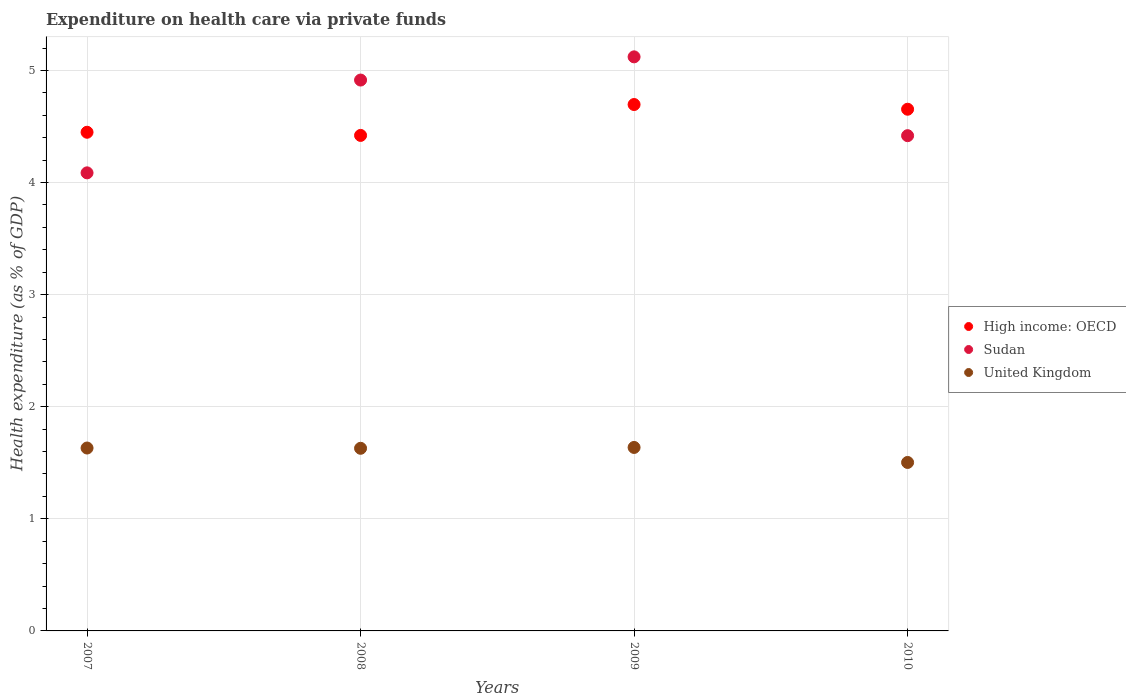What is the expenditure made on health care in Sudan in 2008?
Offer a terse response. 4.91. Across all years, what is the maximum expenditure made on health care in High income: OECD?
Make the answer very short. 4.7. Across all years, what is the minimum expenditure made on health care in United Kingdom?
Your response must be concise. 1.5. In which year was the expenditure made on health care in Sudan minimum?
Give a very brief answer. 2007. What is the total expenditure made on health care in United Kingdom in the graph?
Ensure brevity in your answer.  6.4. What is the difference between the expenditure made on health care in High income: OECD in 2007 and that in 2009?
Keep it short and to the point. -0.25. What is the difference between the expenditure made on health care in United Kingdom in 2009 and the expenditure made on health care in Sudan in 2008?
Your response must be concise. -3.28. What is the average expenditure made on health care in United Kingdom per year?
Offer a very short reply. 1.6. In the year 2009, what is the difference between the expenditure made on health care in High income: OECD and expenditure made on health care in United Kingdom?
Keep it short and to the point. 3.06. What is the ratio of the expenditure made on health care in High income: OECD in 2007 to that in 2010?
Make the answer very short. 0.96. Is the expenditure made on health care in United Kingdom in 2007 less than that in 2009?
Keep it short and to the point. Yes. Is the difference between the expenditure made on health care in High income: OECD in 2009 and 2010 greater than the difference between the expenditure made on health care in United Kingdom in 2009 and 2010?
Keep it short and to the point. No. What is the difference between the highest and the second highest expenditure made on health care in United Kingdom?
Ensure brevity in your answer.  0.01. What is the difference between the highest and the lowest expenditure made on health care in High income: OECD?
Keep it short and to the point. 0.28. In how many years, is the expenditure made on health care in Sudan greater than the average expenditure made on health care in Sudan taken over all years?
Your response must be concise. 2. Does the expenditure made on health care in Sudan monotonically increase over the years?
Give a very brief answer. No. Is the expenditure made on health care in Sudan strictly less than the expenditure made on health care in High income: OECD over the years?
Provide a succinct answer. No. How many years are there in the graph?
Offer a very short reply. 4. What is the difference between two consecutive major ticks on the Y-axis?
Make the answer very short. 1. Does the graph contain any zero values?
Your answer should be very brief. No. What is the title of the graph?
Ensure brevity in your answer.  Expenditure on health care via private funds. What is the label or title of the X-axis?
Offer a very short reply. Years. What is the label or title of the Y-axis?
Your response must be concise. Health expenditure (as % of GDP). What is the Health expenditure (as % of GDP) in High income: OECD in 2007?
Ensure brevity in your answer.  4.45. What is the Health expenditure (as % of GDP) of Sudan in 2007?
Your response must be concise. 4.09. What is the Health expenditure (as % of GDP) in United Kingdom in 2007?
Your answer should be very brief. 1.63. What is the Health expenditure (as % of GDP) in High income: OECD in 2008?
Make the answer very short. 4.42. What is the Health expenditure (as % of GDP) in Sudan in 2008?
Your answer should be compact. 4.91. What is the Health expenditure (as % of GDP) in United Kingdom in 2008?
Ensure brevity in your answer.  1.63. What is the Health expenditure (as % of GDP) of High income: OECD in 2009?
Provide a succinct answer. 4.7. What is the Health expenditure (as % of GDP) of Sudan in 2009?
Your answer should be compact. 5.12. What is the Health expenditure (as % of GDP) in United Kingdom in 2009?
Make the answer very short. 1.64. What is the Health expenditure (as % of GDP) of High income: OECD in 2010?
Your response must be concise. 4.65. What is the Health expenditure (as % of GDP) of Sudan in 2010?
Your answer should be very brief. 4.42. What is the Health expenditure (as % of GDP) in United Kingdom in 2010?
Your answer should be compact. 1.5. Across all years, what is the maximum Health expenditure (as % of GDP) of High income: OECD?
Your response must be concise. 4.7. Across all years, what is the maximum Health expenditure (as % of GDP) of Sudan?
Provide a succinct answer. 5.12. Across all years, what is the maximum Health expenditure (as % of GDP) of United Kingdom?
Your answer should be compact. 1.64. Across all years, what is the minimum Health expenditure (as % of GDP) in High income: OECD?
Offer a very short reply. 4.42. Across all years, what is the minimum Health expenditure (as % of GDP) of Sudan?
Give a very brief answer. 4.09. Across all years, what is the minimum Health expenditure (as % of GDP) of United Kingdom?
Your response must be concise. 1.5. What is the total Health expenditure (as % of GDP) of High income: OECD in the graph?
Give a very brief answer. 18.22. What is the total Health expenditure (as % of GDP) in Sudan in the graph?
Offer a terse response. 18.54. What is the total Health expenditure (as % of GDP) in United Kingdom in the graph?
Ensure brevity in your answer.  6.4. What is the difference between the Health expenditure (as % of GDP) of High income: OECD in 2007 and that in 2008?
Keep it short and to the point. 0.03. What is the difference between the Health expenditure (as % of GDP) in Sudan in 2007 and that in 2008?
Make the answer very short. -0.83. What is the difference between the Health expenditure (as % of GDP) of United Kingdom in 2007 and that in 2008?
Provide a succinct answer. 0. What is the difference between the Health expenditure (as % of GDP) in High income: OECD in 2007 and that in 2009?
Provide a short and direct response. -0.25. What is the difference between the Health expenditure (as % of GDP) in Sudan in 2007 and that in 2009?
Keep it short and to the point. -1.03. What is the difference between the Health expenditure (as % of GDP) in United Kingdom in 2007 and that in 2009?
Provide a short and direct response. -0.01. What is the difference between the Health expenditure (as % of GDP) of High income: OECD in 2007 and that in 2010?
Provide a short and direct response. -0.21. What is the difference between the Health expenditure (as % of GDP) of Sudan in 2007 and that in 2010?
Offer a very short reply. -0.33. What is the difference between the Health expenditure (as % of GDP) in United Kingdom in 2007 and that in 2010?
Offer a very short reply. 0.13. What is the difference between the Health expenditure (as % of GDP) in High income: OECD in 2008 and that in 2009?
Your answer should be very brief. -0.28. What is the difference between the Health expenditure (as % of GDP) of Sudan in 2008 and that in 2009?
Provide a succinct answer. -0.21. What is the difference between the Health expenditure (as % of GDP) in United Kingdom in 2008 and that in 2009?
Your answer should be very brief. -0.01. What is the difference between the Health expenditure (as % of GDP) of High income: OECD in 2008 and that in 2010?
Offer a very short reply. -0.23. What is the difference between the Health expenditure (as % of GDP) in Sudan in 2008 and that in 2010?
Make the answer very short. 0.5. What is the difference between the Health expenditure (as % of GDP) of United Kingdom in 2008 and that in 2010?
Give a very brief answer. 0.13. What is the difference between the Health expenditure (as % of GDP) in High income: OECD in 2009 and that in 2010?
Offer a very short reply. 0.04. What is the difference between the Health expenditure (as % of GDP) of Sudan in 2009 and that in 2010?
Keep it short and to the point. 0.7. What is the difference between the Health expenditure (as % of GDP) in United Kingdom in 2009 and that in 2010?
Your response must be concise. 0.13. What is the difference between the Health expenditure (as % of GDP) of High income: OECD in 2007 and the Health expenditure (as % of GDP) of Sudan in 2008?
Make the answer very short. -0.47. What is the difference between the Health expenditure (as % of GDP) of High income: OECD in 2007 and the Health expenditure (as % of GDP) of United Kingdom in 2008?
Offer a terse response. 2.82. What is the difference between the Health expenditure (as % of GDP) of Sudan in 2007 and the Health expenditure (as % of GDP) of United Kingdom in 2008?
Provide a short and direct response. 2.46. What is the difference between the Health expenditure (as % of GDP) of High income: OECD in 2007 and the Health expenditure (as % of GDP) of Sudan in 2009?
Your response must be concise. -0.67. What is the difference between the Health expenditure (as % of GDP) in High income: OECD in 2007 and the Health expenditure (as % of GDP) in United Kingdom in 2009?
Ensure brevity in your answer.  2.81. What is the difference between the Health expenditure (as % of GDP) in Sudan in 2007 and the Health expenditure (as % of GDP) in United Kingdom in 2009?
Offer a very short reply. 2.45. What is the difference between the Health expenditure (as % of GDP) in High income: OECD in 2007 and the Health expenditure (as % of GDP) in Sudan in 2010?
Offer a terse response. 0.03. What is the difference between the Health expenditure (as % of GDP) of High income: OECD in 2007 and the Health expenditure (as % of GDP) of United Kingdom in 2010?
Provide a short and direct response. 2.95. What is the difference between the Health expenditure (as % of GDP) of Sudan in 2007 and the Health expenditure (as % of GDP) of United Kingdom in 2010?
Your response must be concise. 2.58. What is the difference between the Health expenditure (as % of GDP) of High income: OECD in 2008 and the Health expenditure (as % of GDP) of Sudan in 2009?
Provide a short and direct response. -0.7. What is the difference between the Health expenditure (as % of GDP) of High income: OECD in 2008 and the Health expenditure (as % of GDP) of United Kingdom in 2009?
Ensure brevity in your answer.  2.78. What is the difference between the Health expenditure (as % of GDP) of Sudan in 2008 and the Health expenditure (as % of GDP) of United Kingdom in 2009?
Ensure brevity in your answer.  3.28. What is the difference between the Health expenditure (as % of GDP) of High income: OECD in 2008 and the Health expenditure (as % of GDP) of Sudan in 2010?
Keep it short and to the point. 0. What is the difference between the Health expenditure (as % of GDP) of High income: OECD in 2008 and the Health expenditure (as % of GDP) of United Kingdom in 2010?
Give a very brief answer. 2.92. What is the difference between the Health expenditure (as % of GDP) of Sudan in 2008 and the Health expenditure (as % of GDP) of United Kingdom in 2010?
Offer a very short reply. 3.41. What is the difference between the Health expenditure (as % of GDP) of High income: OECD in 2009 and the Health expenditure (as % of GDP) of Sudan in 2010?
Offer a very short reply. 0.28. What is the difference between the Health expenditure (as % of GDP) in High income: OECD in 2009 and the Health expenditure (as % of GDP) in United Kingdom in 2010?
Provide a short and direct response. 3.19. What is the difference between the Health expenditure (as % of GDP) of Sudan in 2009 and the Health expenditure (as % of GDP) of United Kingdom in 2010?
Provide a short and direct response. 3.62. What is the average Health expenditure (as % of GDP) in High income: OECD per year?
Keep it short and to the point. 4.55. What is the average Health expenditure (as % of GDP) in Sudan per year?
Give a very brief answer. 4.64. What is the average Health expenditure (as % of GDP) of United Kingdom per year?
Give a very brief answer. 1.6. In the year 2007, what is the difference between the Health expenditure (as % of GDP) of High income: OECD and Health expenditure (as % of GDP) of Sudan?
Provide a succinct answer. 0.36. In the year 2007, what is the difference between the Health expenditure (as % of GDP) of High income: OECD and Health expenditure (as % of GDP) of United Kingdom?
Provide a succinct answer. 2.82. In the year 2007, what is the difference between the Health expenditure (as % of GDP) of Sudan and Health expenditure (as % of GDP) of United Kingdom?
Keep it short and to the point. 2.45. In the year 2008, what is the difference between the Health expenditure (as % of GDP) in High income: OECD and Health expenditure (as % of GDP) in Sudan?
Your answer should be very brief. -0.49. In the year 2008, what is the difference between the Health expenditure (as % of GDP) of High income: OECD and Health expenditure (as % of GDP) of United Kingdom?
Offer a terse response. 2.79. In the year 2008, what is the difference between the Health expenditure (as % of GDP) in Sudan and Health expenditure (as % of GDP) in United Kingdom?
Provide a succinct answer. 3.29. In the year 2009, what is the difference between the Health expenditure (as % of GDP) of High income: OECD and Health expenditure (as % of GDP) of Sudan?
Provide a short and direct response. -0.43. In the year 2009, what is the difference between the Health expenditure (as % of GDP) of High income: OECD and Health expenditure (as % of GDP) of United Kingdom?
Provide a short and direct response. 3.06. In the year 2009, what is the difference between the Health expenditure (as % of GDP) of Sudan and Health expenditure (as % of GDP) of United Kingdom?
Keep it short and to the point. 3.48. In the year 2010, what is the difference between the Health expenditure (as % of GDP) in High income: OECD and Health expenditure (as % of GDP) in Sudan?
Your answer should be very brief. 0.24. In the year 2010, what is the difference between the Health expenditure (as % of GDP) of High income: OECD and Health expenditure (as % of GDP) of United Kingdom?
Provide a short and direct response. 3.15. In the year 2010, what is the difference between the Health expenditure (as % of GDP) in Sudan and Health expenditure (as % of GDP) in United Kingdom?
Offer a terse response. 2.92. What is the ratio of the Health expenditure (as % of GDP) in High income: OECD in 2007 to that in 2008?
Your response must be concise. 1.01. What is the ratio of the Health expenditure (as % of GDP) in Sudan in 2007 to that in 2008?
Offer a terse response. 0.83. What is the ratio of the Health expenditure (as % of GDP) of High income: OECD in 2007 to that in 2009?
Make the answer very short. 0.95. What is the ratio of the Health expenditure (as % of GDP) of Sudan in 2007 to that in 2009?
Offer a very short reply. 0.8. What is the ratio of the Health expenditure (as % of GDP) in High income: OECD in 2007 to that in 2010?
Your response must be concise. 0.96. What is the ratio of the Health expenditure (as % of GDP) in Sudan in 2007 to that in 2010?
Provide a short and direct response. 0.92. What is the ratio of the Health expenditure (as % of GDP) in United Kingdom in 2007 to that in 2010?
Keep it short and to the point. 1.09. What is the ratio of the Health expenditure (as % of GDP) in High income: OECD in 2008 to that in 2009?
Your answer should be compact. 0.94. What is the ratio of the Health expenditure (as % of GDP) of Sudan in 2008 to that in 2009?
Your answer should be compact. 0.96. What is the ratio of the Health expenditure (as % of GDP) in United Kingdom in 2008 to that in 2009?
Offer a very short reply. 1. What is the ratio of the Health expenditure (as % of GDP) of High income: OECD in 2008 to that in 2010?
Offer a very short reply. 0.95. What is the ratio of the Health expenditure (as % of GDP) of Sudan in 2008 to that in 2010?
Your answer should be very brief. 1.11. What is the ratio of the Health expenditure (as % of GDP) of United Kingdom in 2008 to that in 2010?
Your answer should be compact. 1.08. What is the ratio of the Health expenditure (as % of GDP) in Sudan in 2009 to that in 2010?
Give a very brief answer. 1.16. What is the ratio of the Health expenditure (as % of GDP) of United Kingdom in 2009 to that in 2010?
Offer a terse response. 1.09. What is the difference between the highest and the second highest Health expenditure (as % of GDP) in High income: OECD?
Make the answer very short. 0.04. What is the difference between the highest and the second highest Health expenditure (as % of GDP) in Sudan?
Your answer should be very brief. 0.21. What is the difference between the highest and the second highest Health expenditure (as % of GDP) of United Kingdom?
Offer a very short reply. 0.01. What is the difference between the highest and the lowest Health expenditure (as % of GDP) of High income: OECD?
Provide a succinct answer. 0.28. What is the difference between the highest and the lowest Health expenditure (as % of GDP) of Sudan?
Provide a short and direct response. 1.03. What is the difference between the highest and the lowest Health expenditure (as % of GDP) of United Kingdom?
Offer a very short reply. 0.13. 